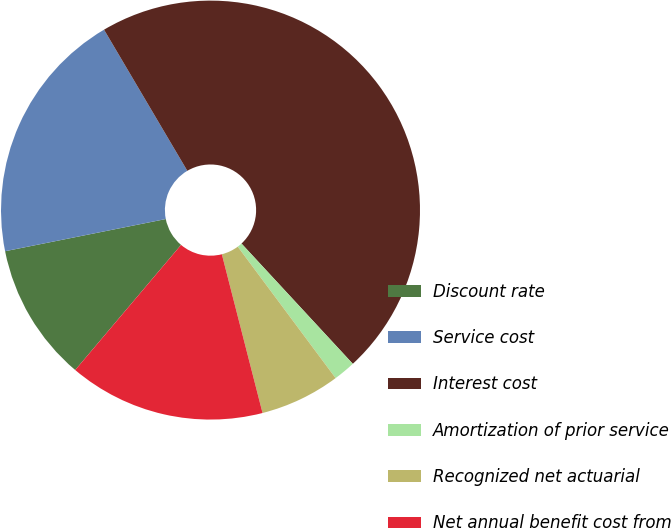Convert chart to OTSL. <chart><loc_0><loc_0><loc_500><loc_500><pie_chart><fcel>Discount rate<fcel>Service cost<fcel>Interest cost<fcel>Amortization of prior service<fcel>Recognized net actuarial<fcel>Net annual benefit cost from<nl><fcel>10.68%<fcel>19.66%<fcel>46.6%<fcel>1.7%<fcel>6.19%<fcel>15.17%<nl></chart> 